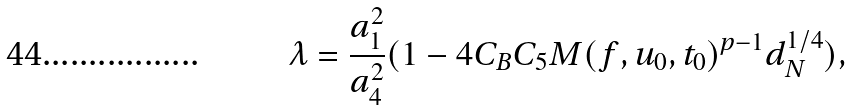Convert formula to latex. <formula><loc_0><loc_0><loc_500><loc_500>\lambda = \frac { a ^ { 2 } _ { 1 } } { a ^ { 2 } _ { 4 } } ( 1 - 4 C _ { B } C _ { 5 } M ( f , u _ { 0 } , t _ { 0 } ) ^ { p - 1 } d ^ { 1 / 4 } _ { N } ) ,</formula> 